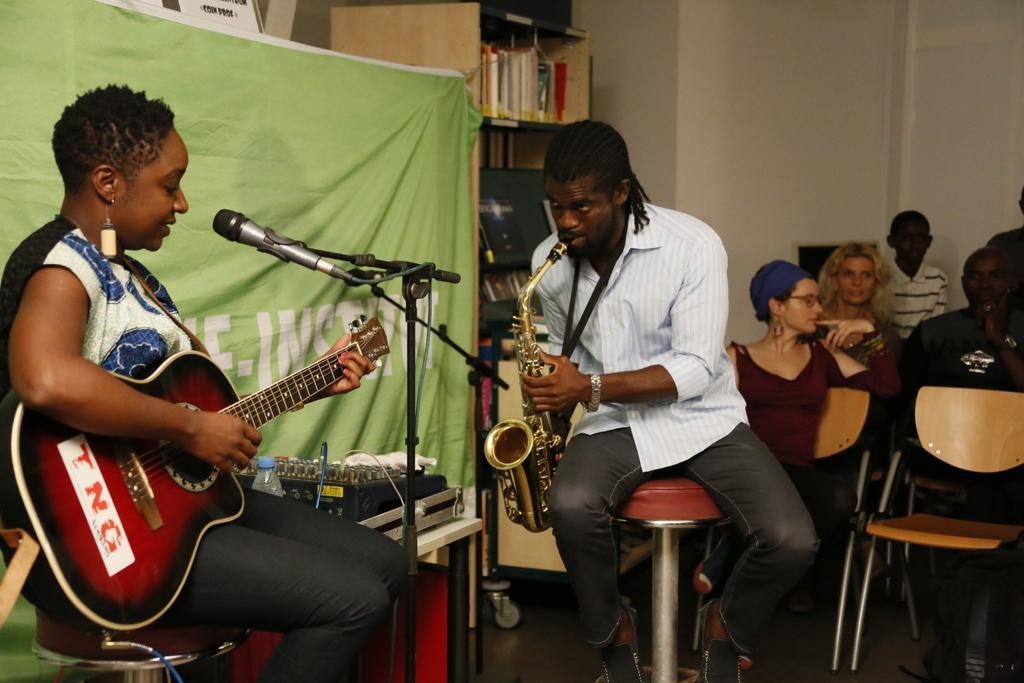Can you describe this image briefly? On the background of the picture we can see a wall and a cupboard in which we can see books. This is a green colour sheet. Here we can see two persons sitting on a chairs in front of a mike and playing some musical instruments. Here we can see few persons sitting on a chair. 